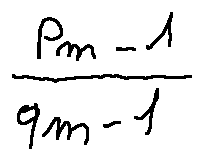<formula> <loc_0><loc_0><loc_500><loc_500>\frac { p _ { m - 1 } } { q _ { m - 1 } }</formula> 